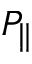<formula> <loc_0><loc_0><loc_500><loc_500>P _ { \| }</formula> 